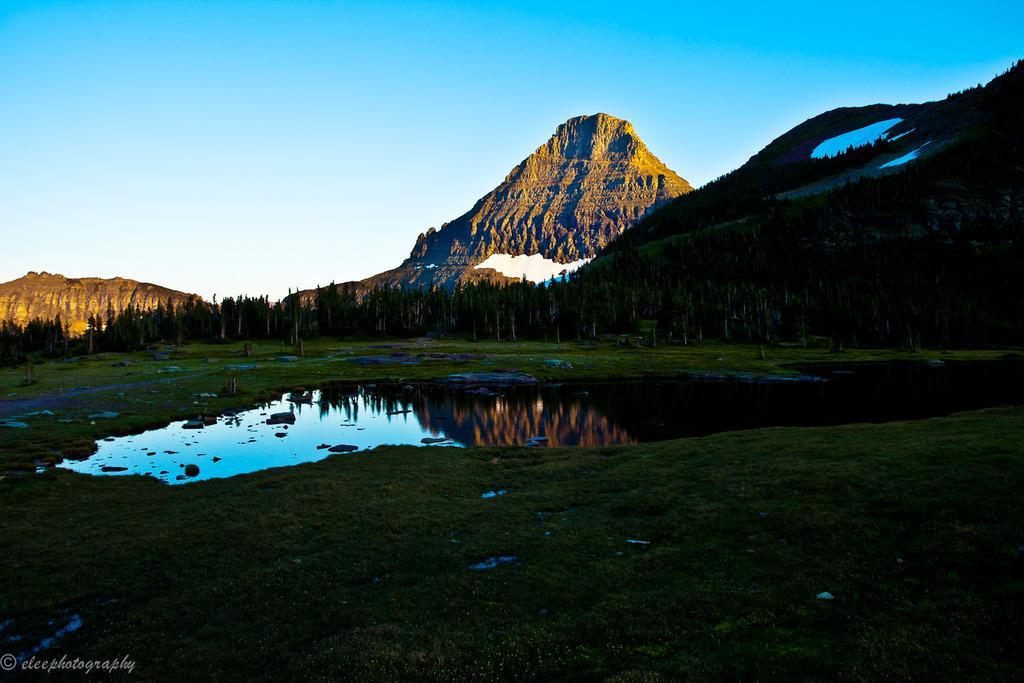In one or two sentences, can you explain what this image depicts? In this picture we can see grass at the bottom, there is water in the middle, in the background there are some trees and hills, we can see the sky at the top of the picture. 